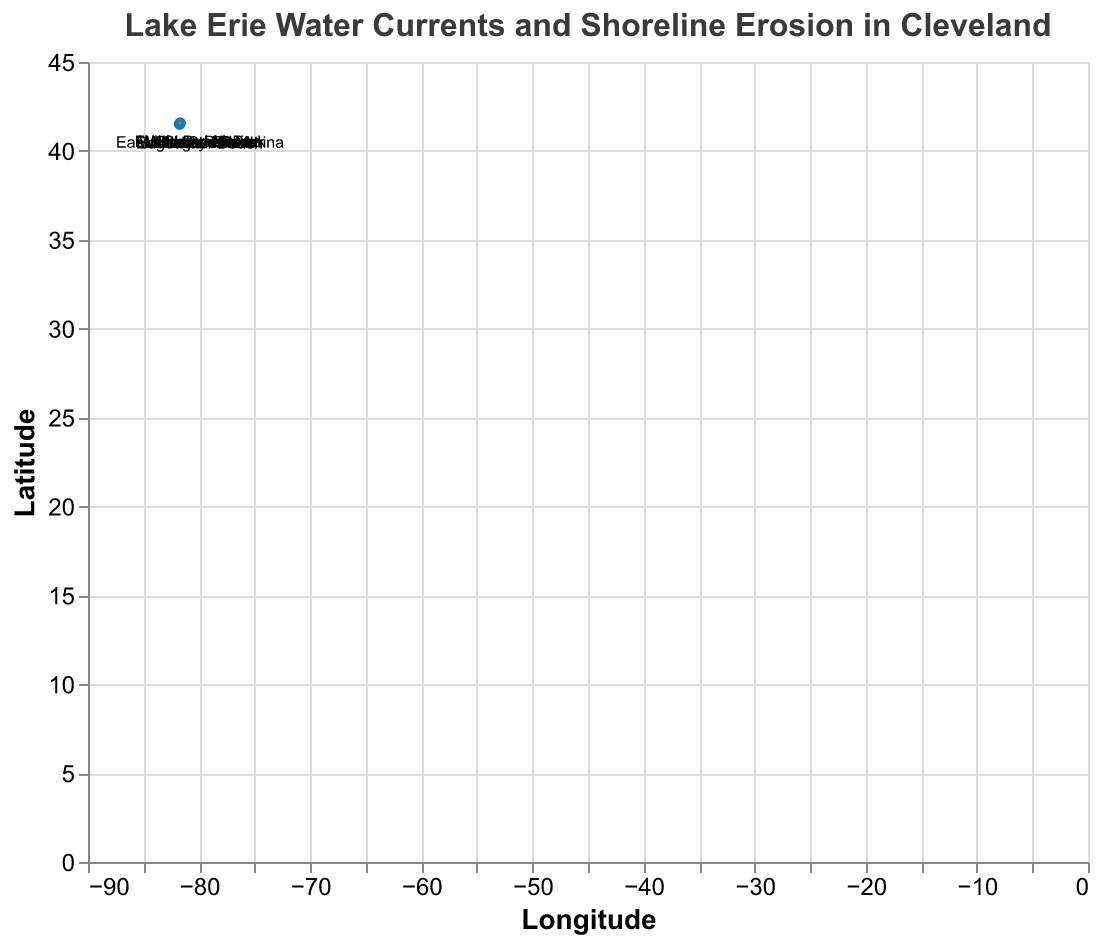What is the title of the figure? The title of the figure is displayed at the top and reads "Lake Erie Water Currents and Shoreline Erosion in Cleveland," which indicates the scope of the data visualized.
Answer: Lake Erie Water Currents and Shoreline Erosion in Cleveland How many locations are displayed on the plot? By counting the data points shown on the plot, both as points and text labels, we can see there are 10 distinct locations.
Answer: 10 What does the color of the points represent? The points are all the same color, blue, so the color does not encode additional information beyond the fact that they mark specific locations.
Answer: Locations What is the longitude of Edgewater Beach? Locate the point labeled "Edgewater Beach" and refer to the tooltip or coordinates; the longitude is -81.75.
Answer: -81.75 What is the direction of the water current at Euclid Beach Park? The direction of the water current is indicated by the vector (u,v). For Euclid Beach Park, the coordinates are (x, y) = (-0.1,0.3), indicating a current direction primarily north.
Answer: North Which location has the strongest northeastern current? Comparing the magnitudes of the vectors, we see Wildwood Marina has a vector (u,v) = (-0.1, 0.4), indicating the strongest northeastern current given the highest upward component.
Answer: Wildwood Marina What is the average u-component of the water currents? Sum all the u-components: (-0.3) + (-0.2) + (-0.1) + (-0.4) + (-0.3) + (-0.2) + (-0.1) + (-0.2) + (-0.3) + (-0.1) = -2.2. Average is -2.2 / 10 = -0.22.
Answer: -0.22 Which location has the smallest vertical component of its water current? By observing the v-components, Huntington Beach has a component of 0.0, which is the smallest (no vertical movement).
Answer: Huntington Beach Do all water currents show a westward direction? Compare all u-components; all are negative, indicating a westward movement.
Answer: Yes At which location is shoreline erosion potentially the highest, based on the current magnitude? The magnitude of vectors can hint at erosion potential. Calculate the magnitude sqrt(u^2 + v^2) for each point to find Wildwood Marina, with magnitude sqrt((-0.1)^2 + (0.4)^2) = 0.41, indicating high erosion potential.
Answer: Wildwood Marina 